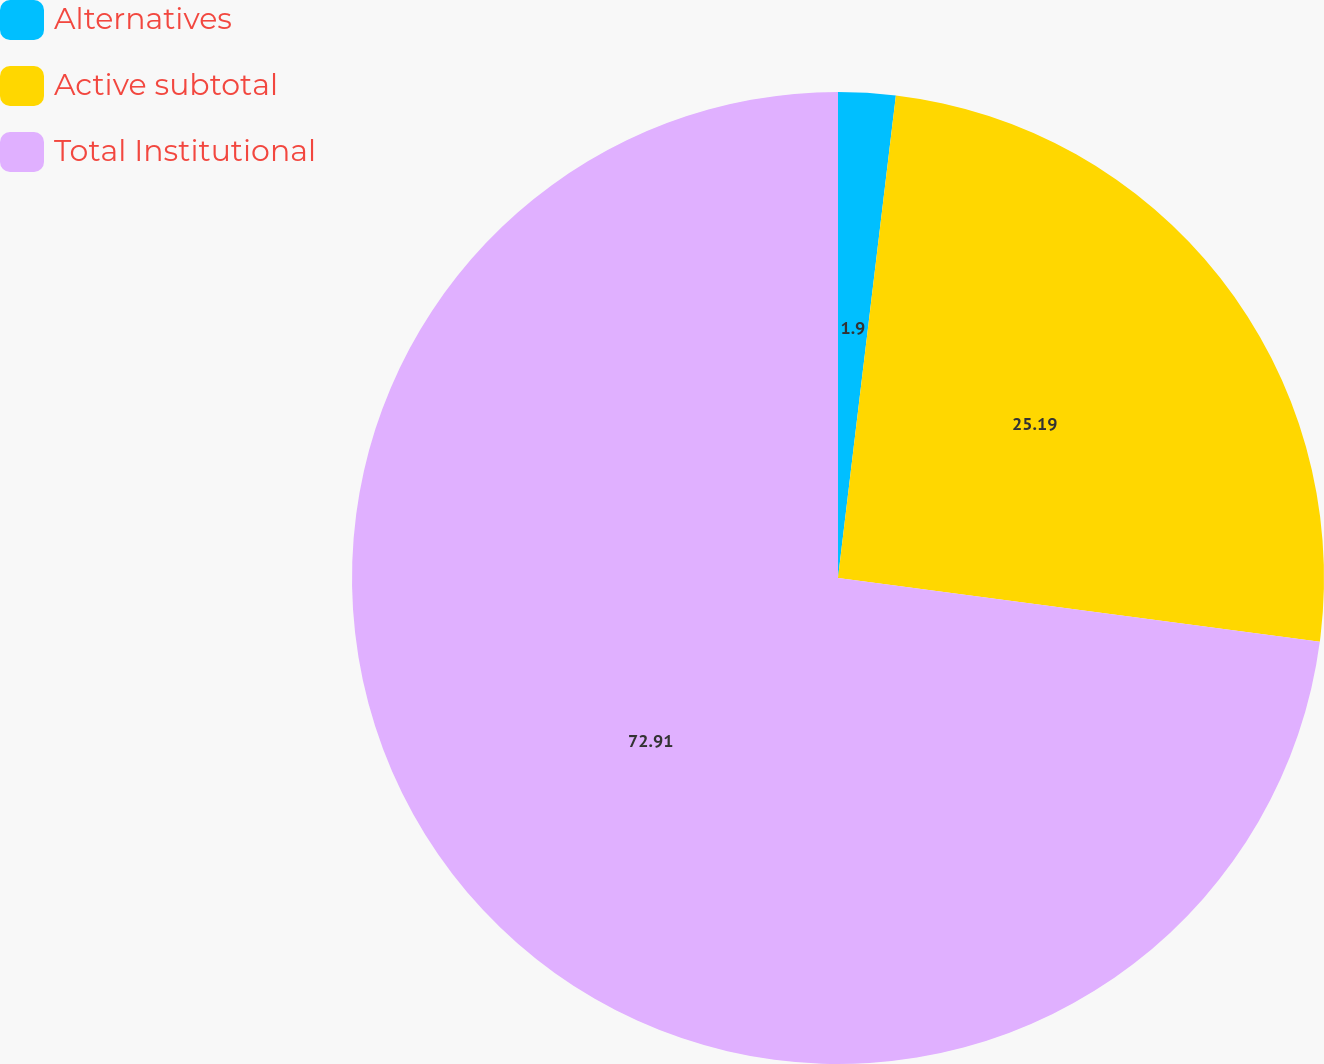Convert chart to OTSL. <chart><loc_0><loc_0><loc_500><loc_500><pie_chart><fcel>Alternatives<fcel>Active subtotal<fcel>Total Institutional<nl><fcel>1.9%<fcel>25.19%<fcel>72.9%<nl></chart> 